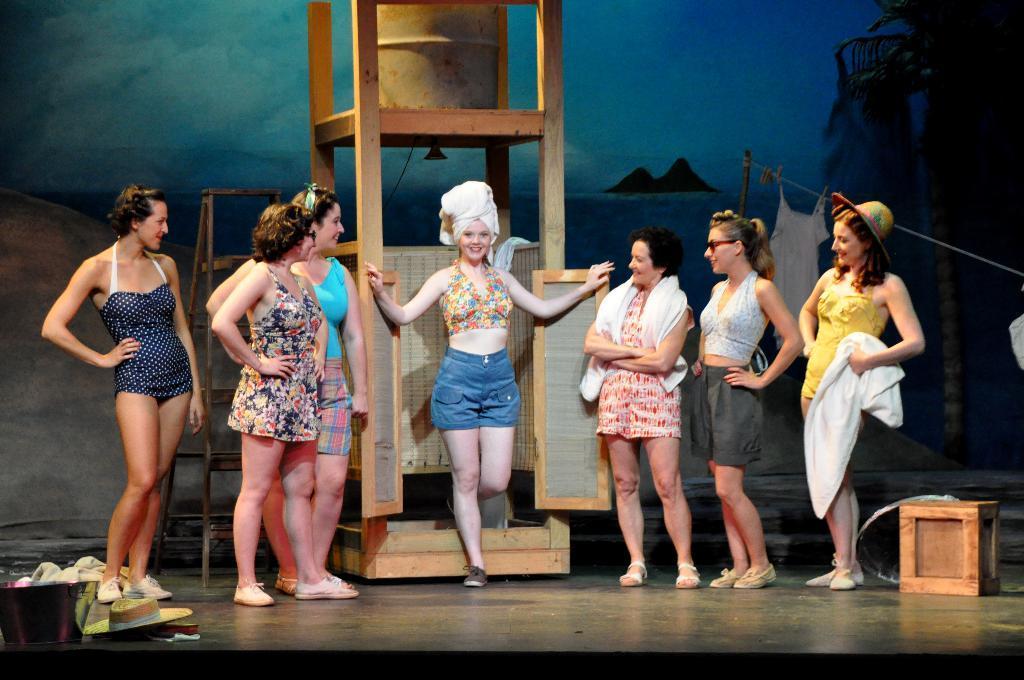In one or two sentences, can you explain what this image depicts? In this image I can see number of women are standing on the stage which is black in color and on the stage I can see few clothes, a hat, a wooden box and a wooden structure and I can see a ladder on the stage. In the background I can see a huge banner in which I can see some water, few mountains and the sky. 